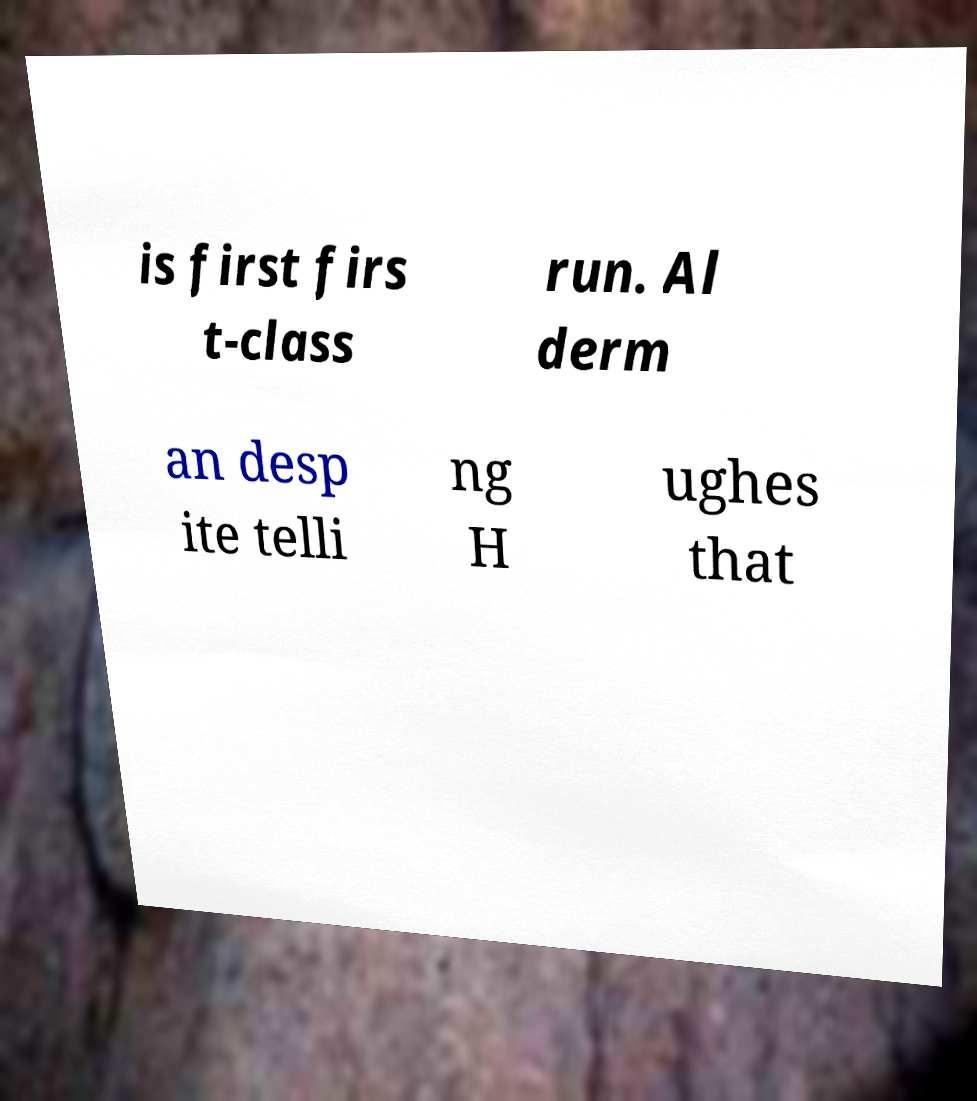Please read and relay the text visible in this image. What does it say? is first firs t-class run. Al derm an desp ite telli ng H ughes that 